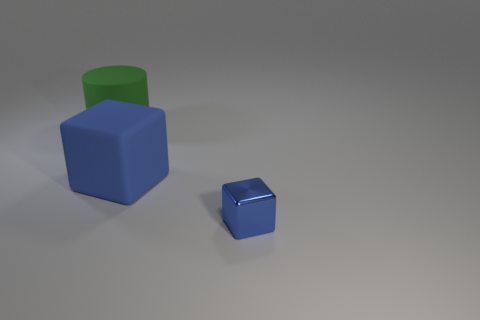Add 1 big red matte cylinders. How many objects exist? 4 Subtract all purple cylinders. Subtract all cyan blocks. How many cylinders are left? 1 Subtract all blocks. How many objects are left? 1 Add 2 small matte cubes. How many small matte cubes exist? 2 Subtract 1 green cylinders. How many objects are left? 2 Subtract all cyan things. Subtract all big green things. How many objects are left? 2 Add 3 large blue things. How many large blue things are left? 4 